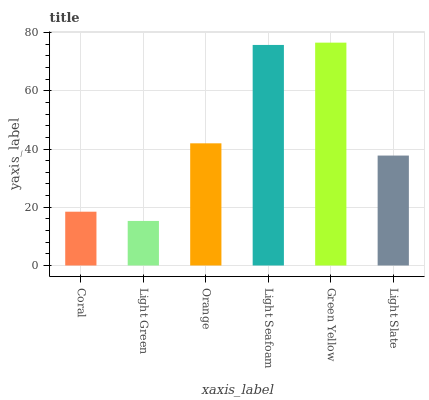Is Light Green the minimum?
Answer yes or no. Yes. Is Green Yellow the maximum?
Answer yes or no. Yes. Is Orange the minimum?
Answer yes or no. No. Is Orange the maximum?
Answer yes or no. No. Is Orange greater than Light Green?
Answer yes or no. Yes. Is Light Green less than Orange?
Answer yes or no. Yes. Is Light Green greater than Orange?
Answer yes or no. No. Is Orange less than Light Green?
Answer yes or no. No. Is Orange the high median?
Answer yes or no. Yes. Is Light Slate the low median?
Answer yes or no. Yes. Is Light Green the high median?
Answer yes or no. No. Is Coral the low median?
Answer yes or no. No. 